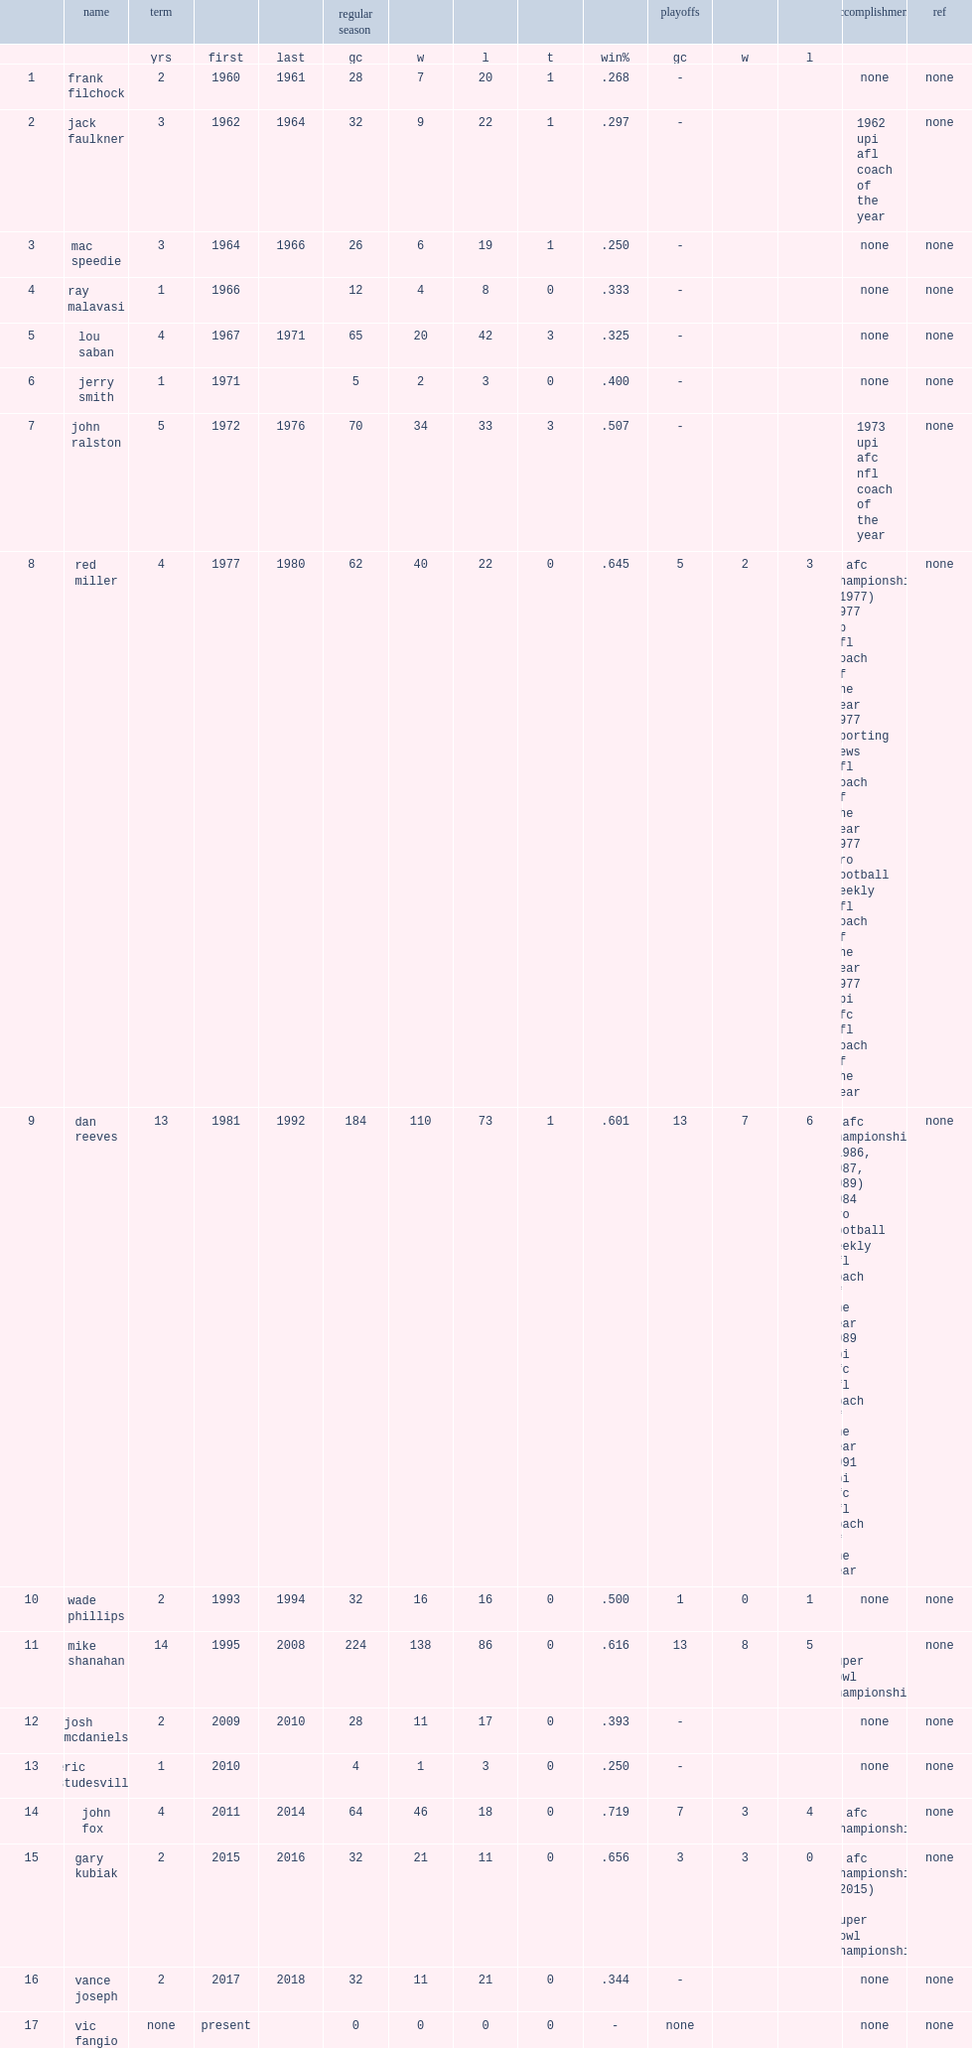Which year was the last year that gary kubiak coached broncos ? 2016.0. 